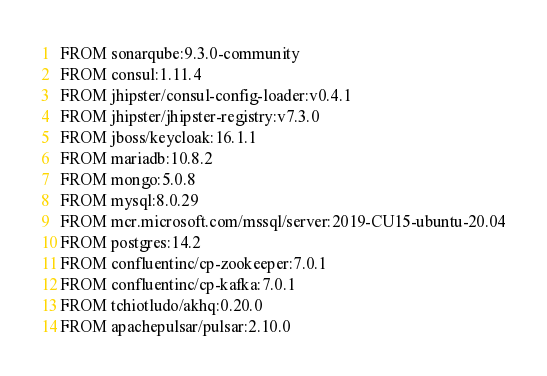Convert code to text. <code><loc_0><loc_0><loc_500><loc_500><_Dockerfile_>FROM sonarqube:9.3.0-community
FROM consul:1.11.4
FROM jhipster/consul-config-loader:v0.4.1
FROM jhipster/jhipster-registry:v7.3.0
FROM jboss/keycloak:16.1.1
FROM mariadb:10.8.2
FROM mongo:5.0.8
FROM mysql:8.0.29
FROM mcr.microsoft.com/mssql/server:2019-CU15-ubuntu-20.04
FROM postgres:14.2
FROM confluentinc/cp-zookeeper:7.0.1
FROM confluentinc/cp-kafka:7.0.1
FROM tchiotludo/akhq:0.20.0
FROM apachepulsar/pulsar:2.10.0
</code> 